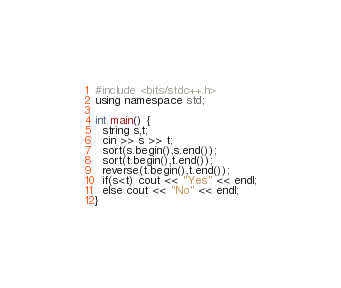Convert code to text. <code><loc_0><loc_0><loc_500><loc_500><_C++_>#include <bits/stdc++.h>
using namespace std;

int main() {
  string s,t;
  cin >> s >> t;
  sort(s.begin(),s.end());
  sort(t.begin(),t.end());
  reverse(t.begin(),t.end());
  if(s<t) cout << "Yes" << endl;
  else cout << "No" << endl;
}</code> 